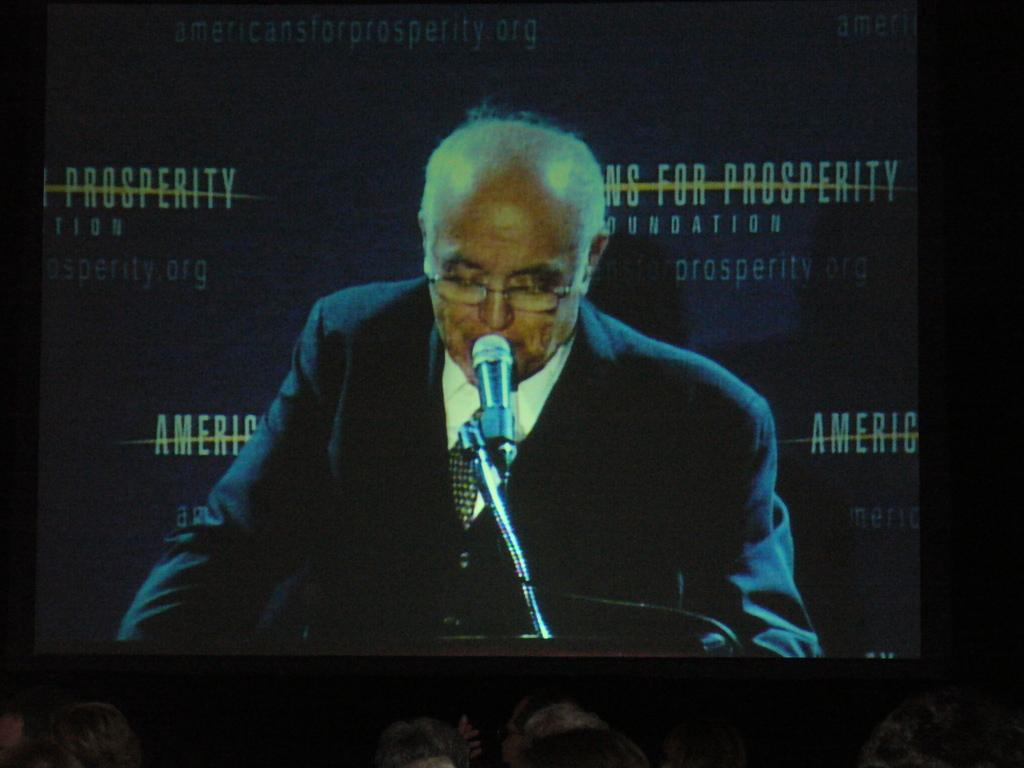What is the main object in the middle of the image? There is a projector screen in the middle of the image. What is the man in the image doing? The man is speaking into a microphone in the image. Can you describe the people at the bottom of the image? There are people at the bottom of the image. What type of fruit is being dropped by the turkey in the image? There is no fruit or turkey present in the image. 